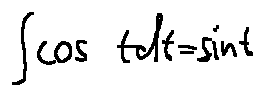Convert formula to latex. <formula><loc_0><loc_0><loc_500><loc_500>\int \cos t d t = \sin t</formula> 